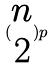<formula> <loc_0><loc_0><loc_500><loc_500>( \begin{matrix} n \\ 2 \end{matrix} ) p</formula> 